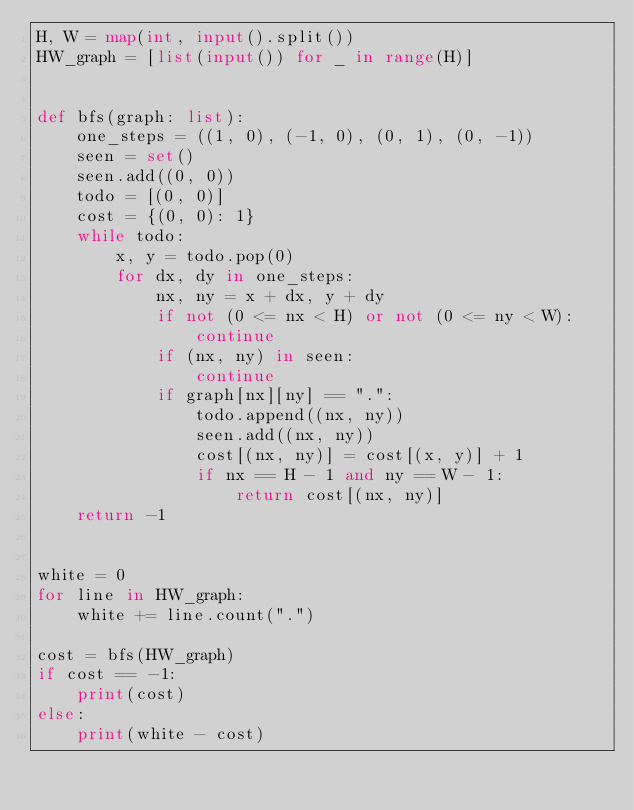Convert code to text. <code><loc_0><loc_0><loc_500><loc_500><_Python_>H, W = map(int, input().split())
HW_graph = [list(input()) for _ in range(H)]


def bfs(graph: list):
    one_steps = ((1, 0), (-1, 0), (0, 1), (0, -1))
    seen = set()
    seen.add((0, 0))
    todo = [(0, 0)]
    cost = {(0, 0): 1}
    while todo:
        x, y = todo.pop(0)
        for dx, dy in one_steps:
            nx, ny = x + dx, y + dy
            if not (0 <= nx < H) or not (0 <= ny < W):
                continue
            if (nx, ny) in seen:
                continue
            if graph[nx][ny] == ".":
                todo.append((nx, ny))
                seen.add((nx, ny))
                cost[(nx, ny)] = cost[(x, y)] + 1
                if nx == H - 1 and ny == W - 1:
                    return cost[(nx, ny)]
    return -1


white = 0
for line in HW_graph:
    white += line.count(".")

cost = bfs(HW_graph)
if cost == -1:
    print(cost)
else:
    print(white - cost)
</code> 